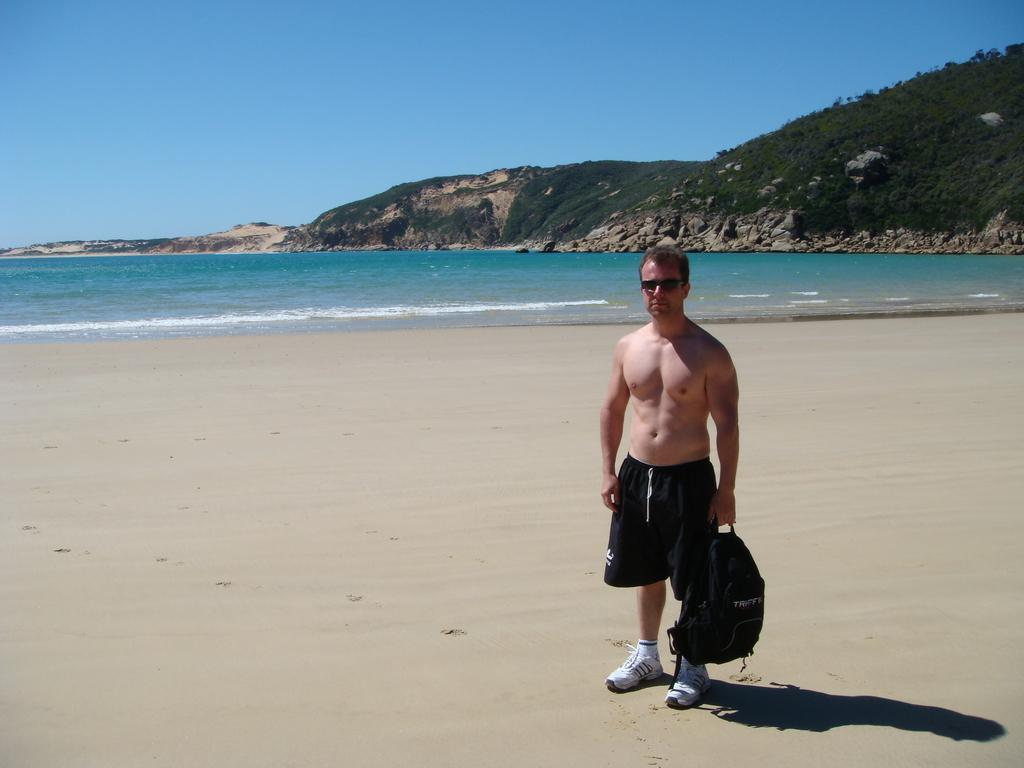What is the man in the image doing? The man is standing in the image. What is the man holding in his hand? The man is holding a bag in his hand. What can be seen in the background of the image? There is water visible in the image, as well as trees on a hill. What is the color of the sky in the image? The sky is blue in the image. What type of crown is the man wearing in the image? There is no crown visible in the image; the man is simply standing and holding a bag. How many haircuts does the man have in the image? The man's haircut cannot be determined from the image, as it only shows him standing and holding a bag. 